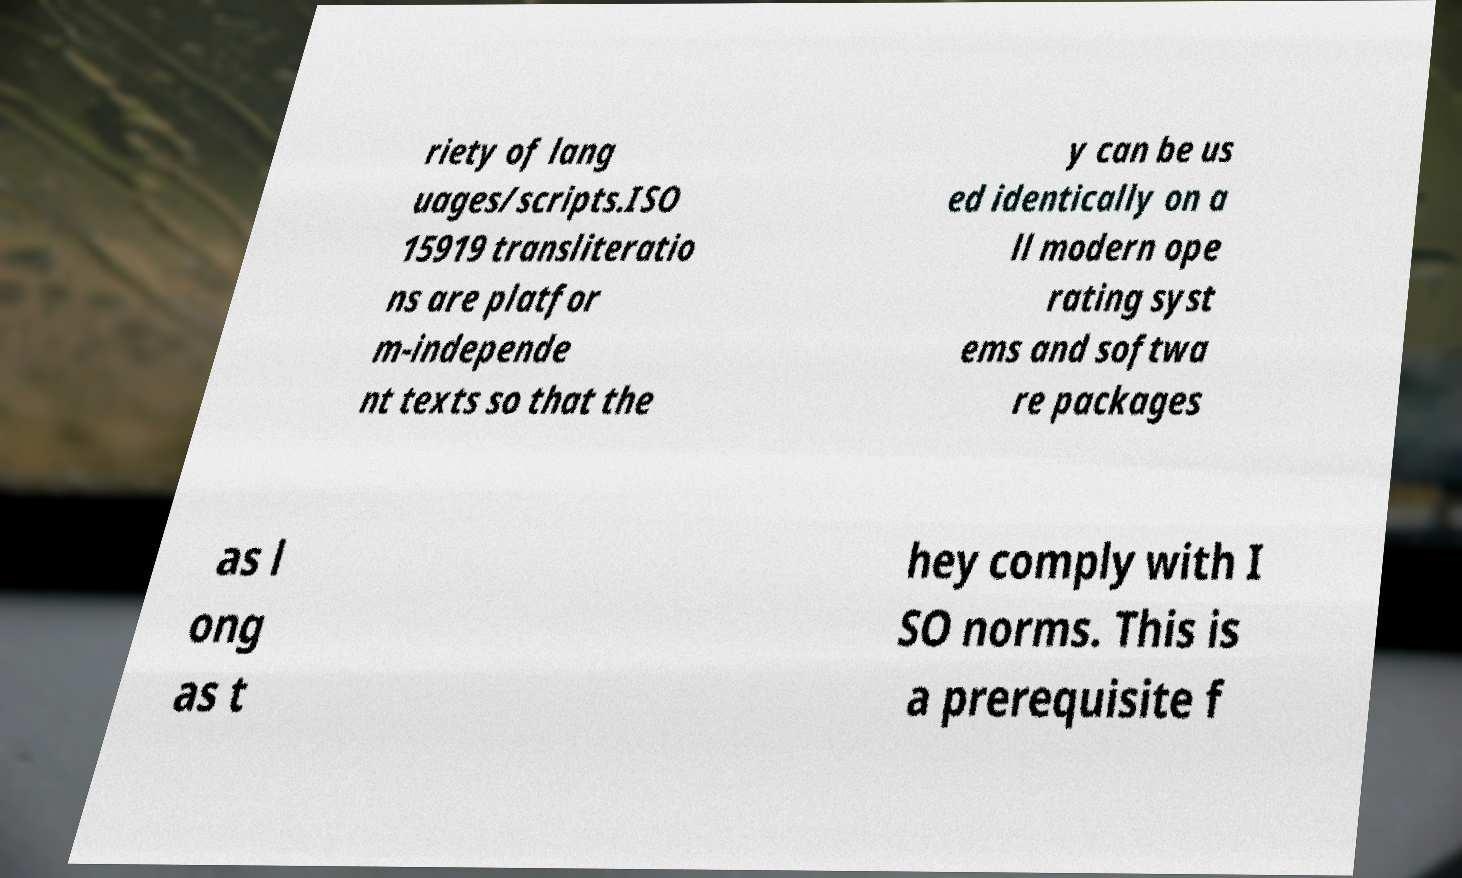Could you assist in decoding the text presented in this image and type it out clearly? riety of lang uages/scripts.ISO 15919 transliteratio ns are platfor m-independe nt texts so that the y can be us ed identically on a ll modern ope rating syst ems and softwa re packages as l ong as t hey comply with I SO norms. This is a prerequisite f 